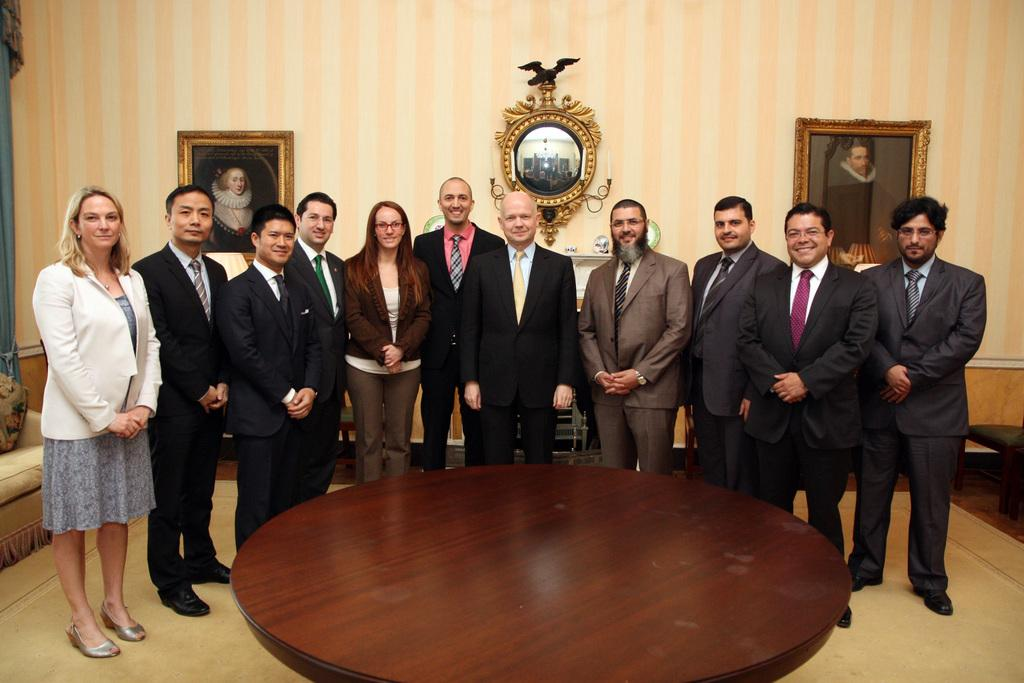How many people are in the image? There is a group of people in the image. Where are the people located in the image? The people are standing in a room. What can be seen on the wall in the image? There are photo frames on the wall in the image. What piece of furniture is present in the image? There is a table in the image. How many coils can be seen on the people's noses in the image? There are no coils visible on the people's noses in the image. Are there any lizards present in the image? There are no lizards present in the image. 